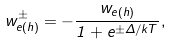<formula> <loc_0><loc_0><loc_500><loc_500>w _ { e ( h ) } ^ { \pm } = - \frac { w _ { e ( h ) } } { 1 + e ^ { \pm \Delta / k T } } ,</formula> 